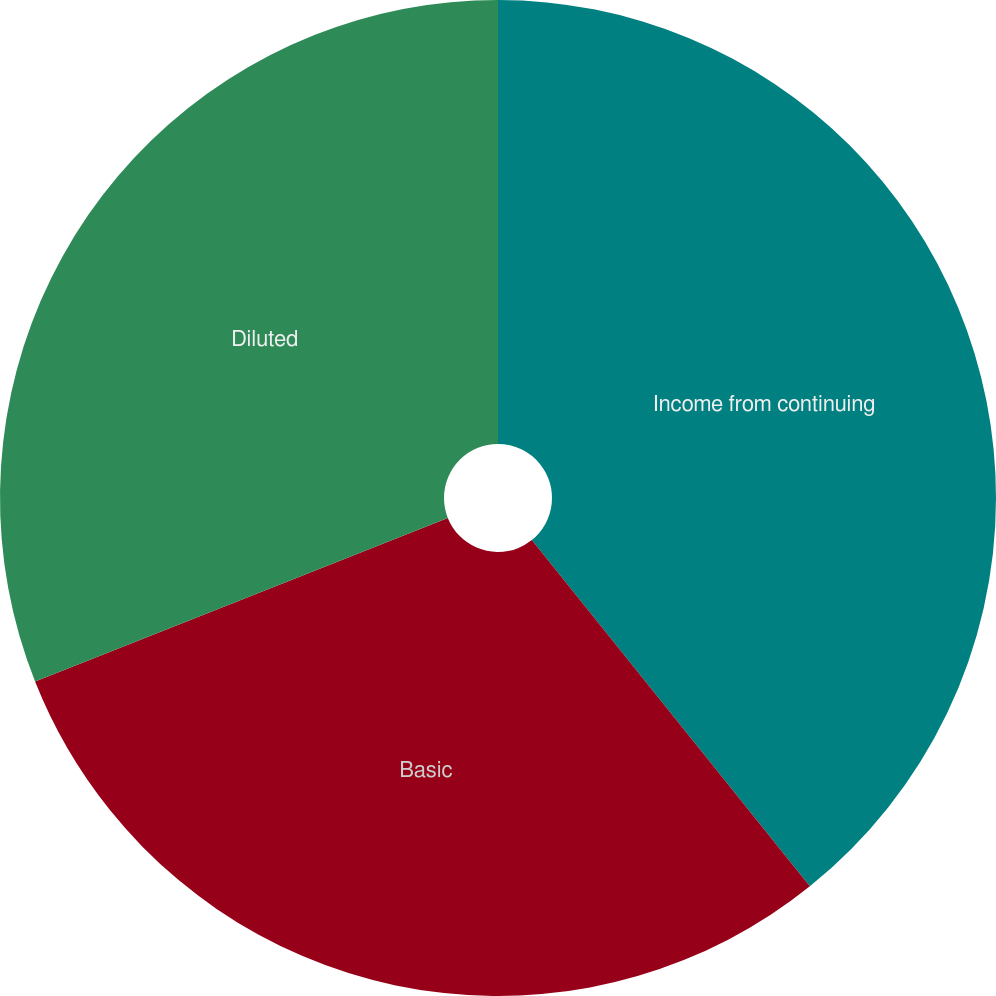Convert chart. <chart><loc_0><loc_0><loc_500><loc_500><pie_chart><fcel>Income from continuing<fcel>Basic<fcel>Diluted<nl><fcel>39.23%<fcel>29.76%<fcel>31.01%<nl></chart> 